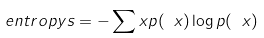Convert formula to latex. <formula><loc_0><loc_0><loc_500><loc_500>\ e n t r o p y s = - \sum _ { \ } x p ( \ x ) \log p ( \ x )</formula> 